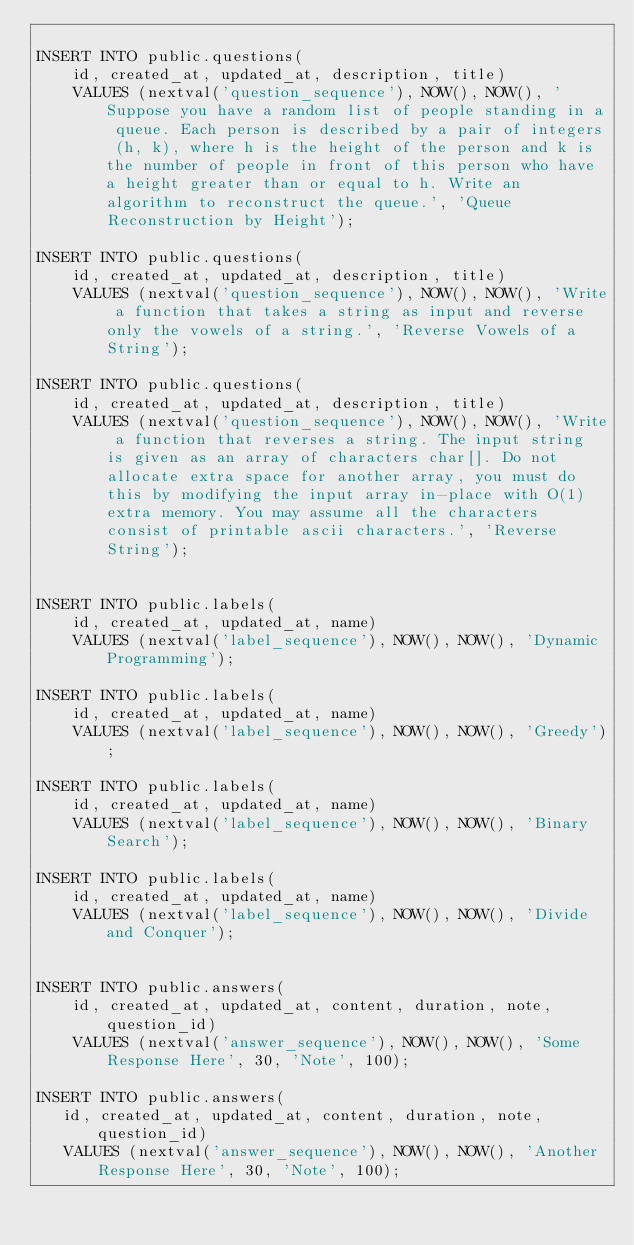<code> <loc_0><loc_0><loc_500><loc_500><_SQL_>
INSERT INTO public.questions(
	id, created_at, updated_at, description, title)
	VALUES (nextval('question_sequence'), NOW(), NOW(), 'Suppose you have a random list of people standing in a queue. Each person is described by a pair of integers (h, k), where h is the height of the person and k is the number of people in front of this person who have a height greater than or equal to h. Write an algorithm to reconstruct the queue.', 'Queue Reconstruction by Height');

INSERT INTO public.questions(
	id, created_at, updated_at, description, title)
	VALUES (nextval('question_sequence'), NOW(), NOW(), 'Write a function that takes a string as input and reverse only the vowels of a string.', 'Reverse Vowels of a String');

INSERT INTO public.questions(
	id, created_at, updated_at, description, title)
	VALUES (nextval('question_sequence'), NOW(), NOW(), 'Write a function that reverses a string. The input string is given as an array of characters char[]. Do not allocate extra space for another array, you must do this by modifying the input array in-place with O(1) extra memory. You may assume all the characters consist of printable ascii characters.', 'Reverse String');


INSERT INTO public.labels(
	id, created_at, updated_at, name)
	VALUES (nextval('label_sequence'), NOW(), NOW(), 'Dynamic Programming');

INSERT INTO public.labels(
	id, created_at, updated_at, name)
	VALUES (nextval('label_sequence'), NOW(), NOW(), 'Greedy');

INSERT INTO public.labels(
	id, created_at, updated_at, name)
	VALUES (nextval('label_sequence'), NOW(), NOW(), 'Binary Search');

INSERT INTO public.labels(
	id, created_at, updated_at, name)
	VALUES (nextval('label_sequence'), NOW(), NOW(), 'Divide and Conquer');


INSERT INTO public.answers(
    id, created_at, updated_at, content, duration, note, question_id)
    VALUES (nextval('answer_sequence'), NOW(), NOW(), 'Some Response Here', 30, 'Note', 100);

INSERT INTO public.answers(
   id, created_at, updated_at, content, duration, note, question_id)
   VALUES (nextval('answer_sequence'), NOW(), NOW(), 'Another Response Here', 30, 'Note', 100);</code> 